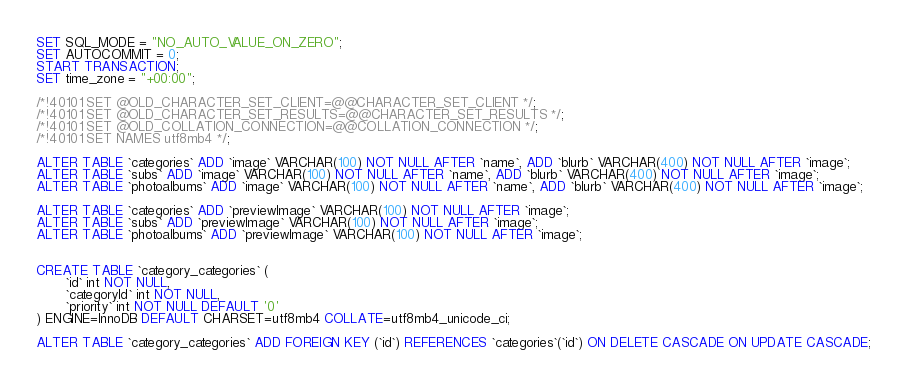Convert code to text. <code><loc_0><loc_0><loc_500><loc_500><_SQL_>SET SQL_MODE = "NO_AUTO_VALUE_ON_ZERO";
SET AUTOCOMMIT = 0;
START TRANSACTION;
SET time_zone = "+00:00";

/*!40101 SET @OLD_CHARACTER_SET_CLIENT=@@CHARACTER_SET_CLIENT */;
/*!40101 SET @OLD_CHARACTER_SET_RESULTS=@@CHARACTER_SET_RESULTS */;
/*!40101 SET @OLD_COLLATION_CONNECTION=@@COLLATION_CONNECTION */;
/*!40101 SET NAMES utf8mb4 */;

ALTER TABLE `categories` ADD `image` VARCHAR(100) NOT NULL AFTER `name`, ADD `blurb` VARCHAR(400) NOT NULL AFTER `image`;
ALTER TABLE `subs` ADD `image` VARCHAR(100) NOT NULL AFTER `name`, ADD `blurb` VARCHAR(400) NOT NULL AFTER `image`;
ALTER TABLE `photoalbums` ADD `image` VARCHAR(100) NOT NULL AFTER `name`, ADD `blurb` VARCHAR(400) NOT NULL AFTER `image`;

ALTER TABLE `categories` ADD `previewImage` VARCHAR(100) NOT NULL AFTER `image`;
ALTER TABLE `subs` ADD `previewImage` VARCHAR(100) NOT NULL AFTER `image`;
ALTER TABLE `photoalbums` ADD `previewImage` VARCHAR(100) NOT NULL AFTER `image`;


CREATE TABLE `category_categories` (
       `id` int NOT NULL,
       `categoryId` int NOT NULL,
       `priority` int NOT NULL DEFAULT '0'
) ENGINE=InnoDB DEFAULT CHARSET=utf8mb4 COLLATE=utf8mb4_unicode_ci;

ALTER TABLE `category_categories` ADD FOREIGN KEY (`id`) REFERENCES `categories`(`id`) ON DELETE CASCADE ON UPDATE CASCADE;</code> 